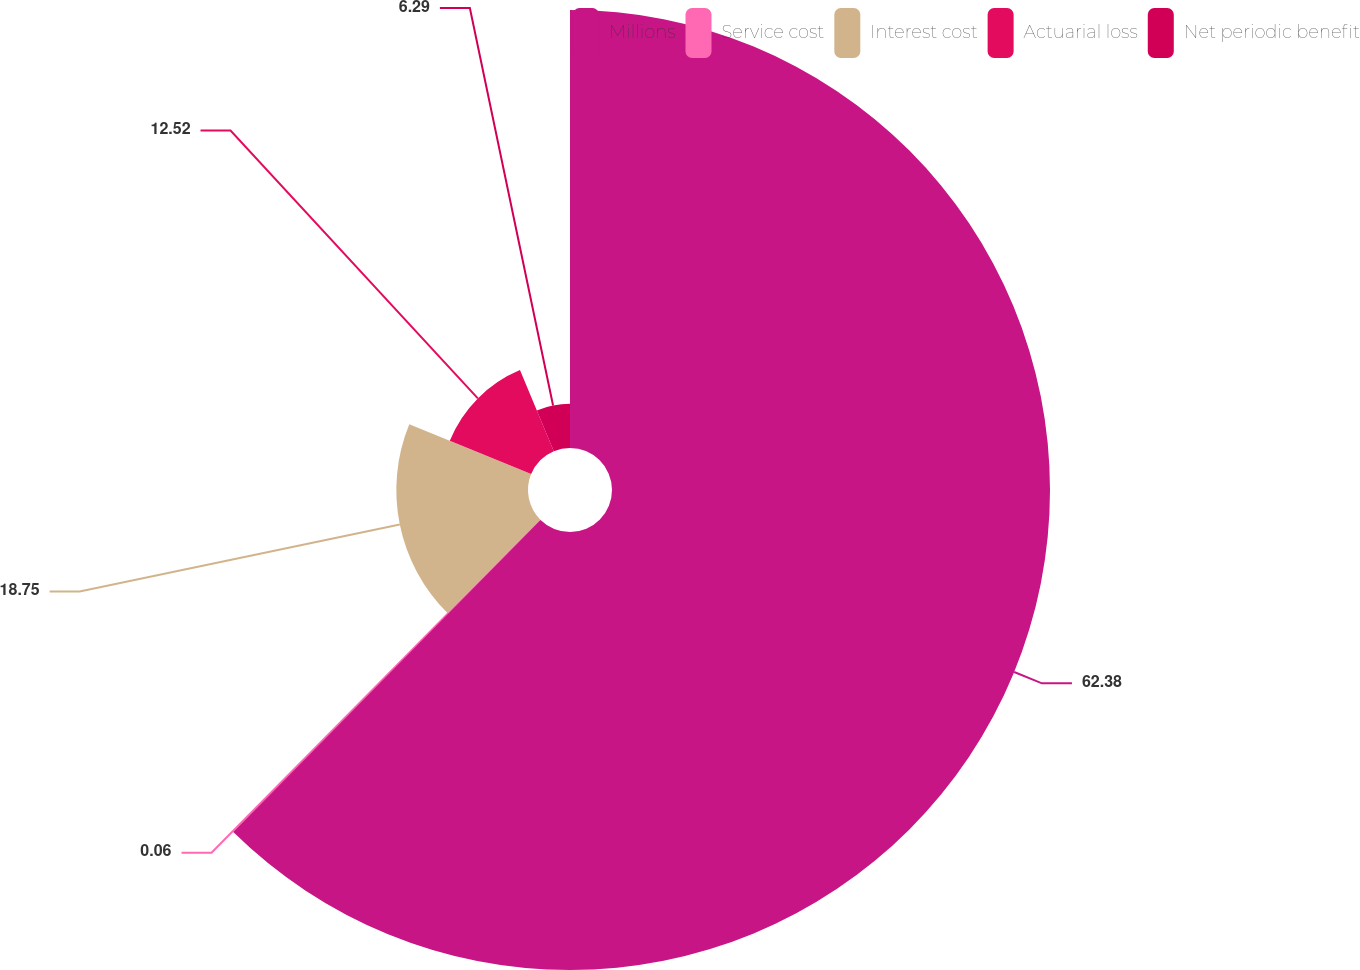<chart> <loc_0><loc_0><loc_500><loc_500><pie_chart><fcel>Millions<fcel>Service cost<fcel>Interest cost<fcel>Actuarial loss<fcel>Net periodic benefit<nl><fcel>62.37%<fcel>0.06%<fcel>18.75%<fcel>12.52%<fcel>6.29%<nl></chart> 